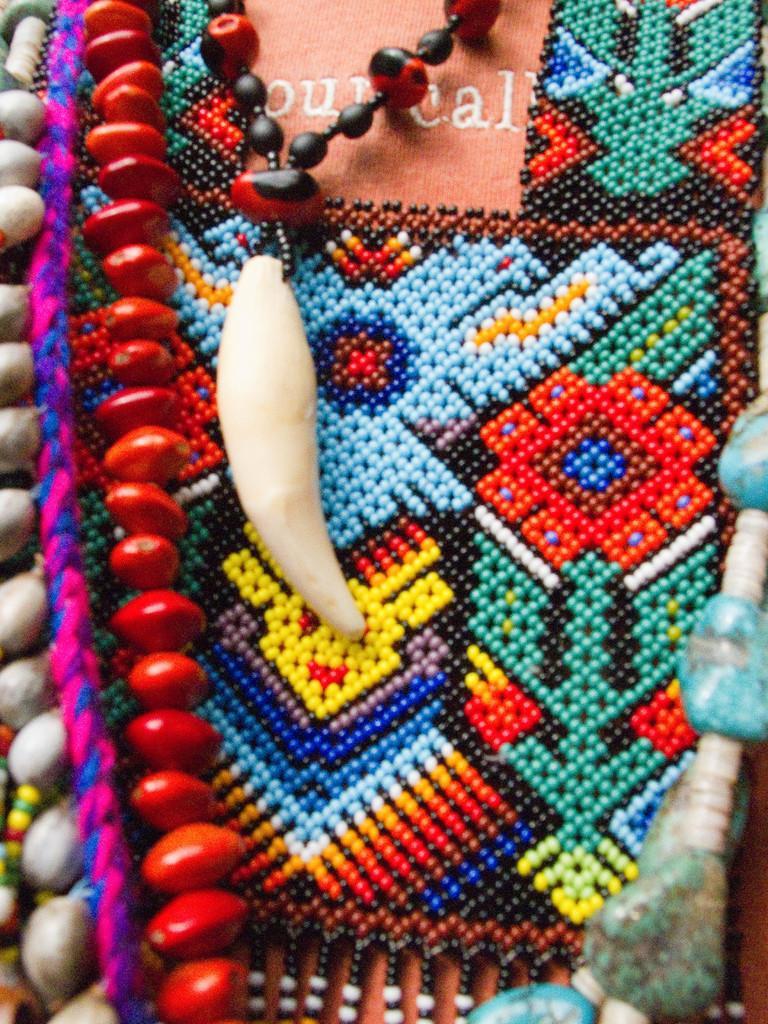Please provide a concise description of this image. In this picture we can see chains and craft. 